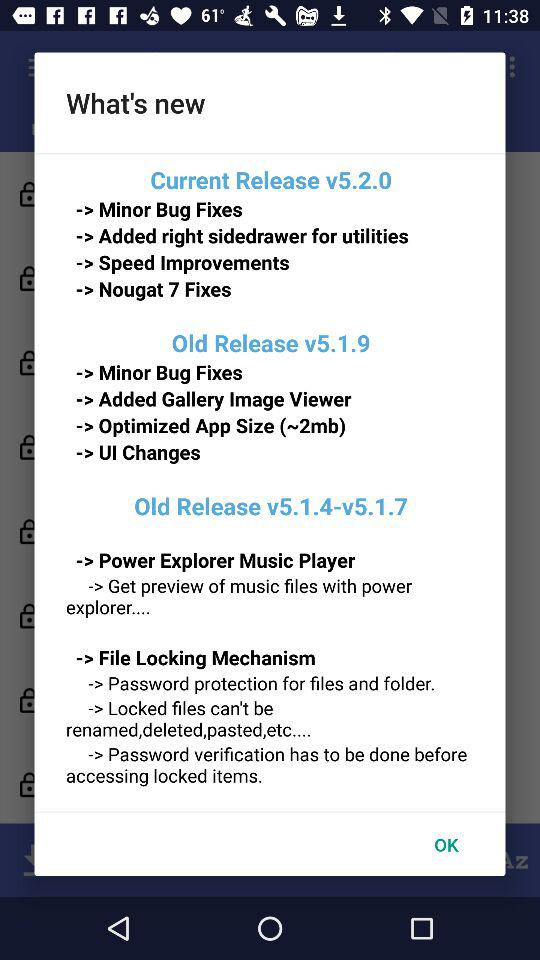What is the optimized app size in the old release of version 5.1.9? The optimized app size in the old release of version 5.1.9 is 2 MB. 